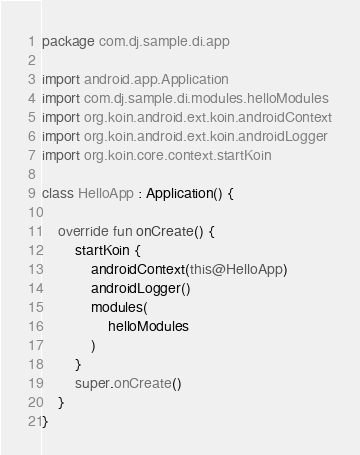<code> <loc_0><loc_0><loc_500><loc_500><_Kotlin_>package com.dj.sample.di.app

import android.app.Application
import com.dj.sample.di.modules.helloModules
import org.koin.android.ext.koin.androidContext
import org.koin.android.ext.koin.androidLogger
import org.koin.core.context.startKoin

class HelloApp : Application() {

    override fun onCreate() {
        startKoin {
            androidContext(this@HelloApp)
            androidLogger()
            modules(
                helloModules
            )
        }
        super.onCreate()
    }
}</code> 